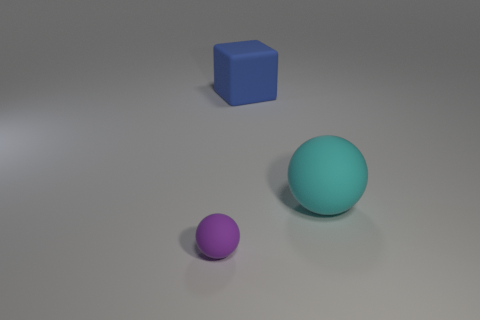Is there anything else that has the same size as the purple matte sphere?
Offer a terse response. No. How many red objects are either spheres or small matte balls?
Give a very brief answer. 0. What number of other things are the same shape as the blue object?
Your answer should be very brief. 0. Do the small ball and the blue object have the same material?
Offer a terse response. Yes. There is a object that is in front of the matte cube and behind the purple rubber thing; what material is it?
Make the answer very short. Rubber. What color is the rubber ball in front of the big rubber ball?
Give a very brief answer. Purple. Is the number of rubber things left of the big cyan rubber thing greater than the number of blue objects?
Your answer should be very brief. Yes. What number of other things are the same size as the purple sphere?
Ensure brevity in your answer.  0. There is a small object; what number of purple rubber objects are left of it?
Keep it short and to the point. 0. Are there the same number of cyan matte things that are behind the small purple ball and big cubes in front of the cyan rubber sphere?
Make the answer very short. No. 